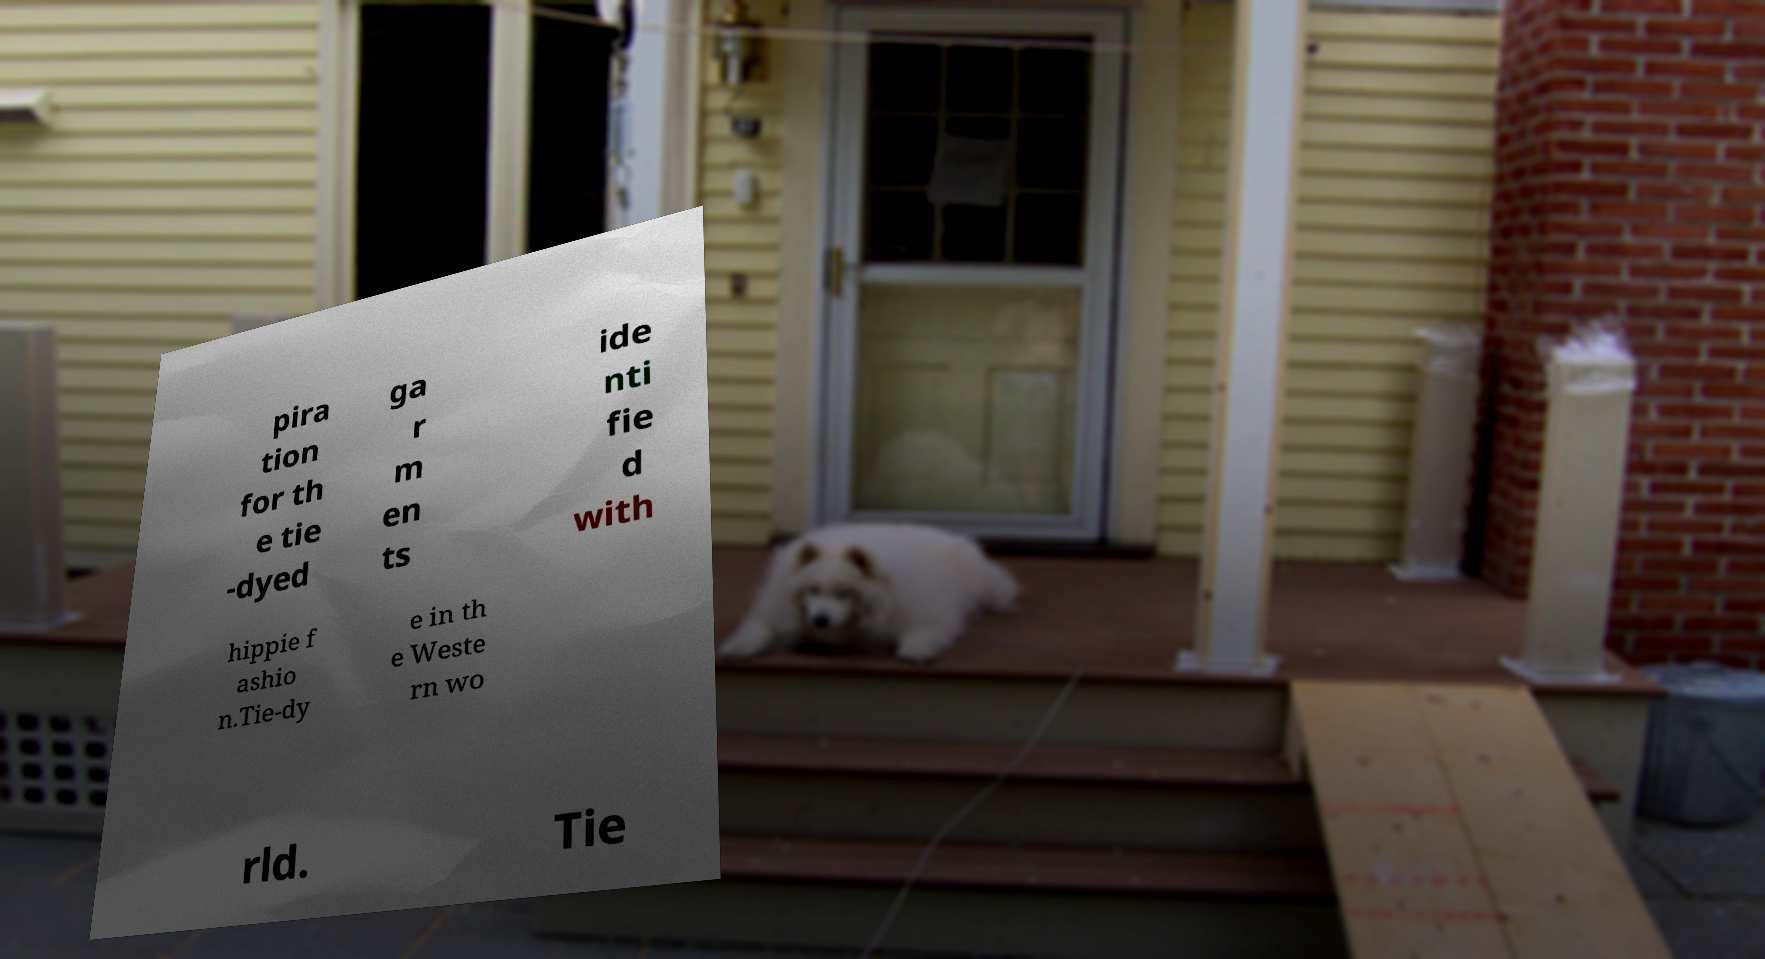Could you assist in decoding the text presented in this image and type it out clearly? pira tion for th e tie -dyed ga r m en ts ide nti fie d with hippie f ashio n.Tie-dy e in th e Weste rn wo rld. Tie 